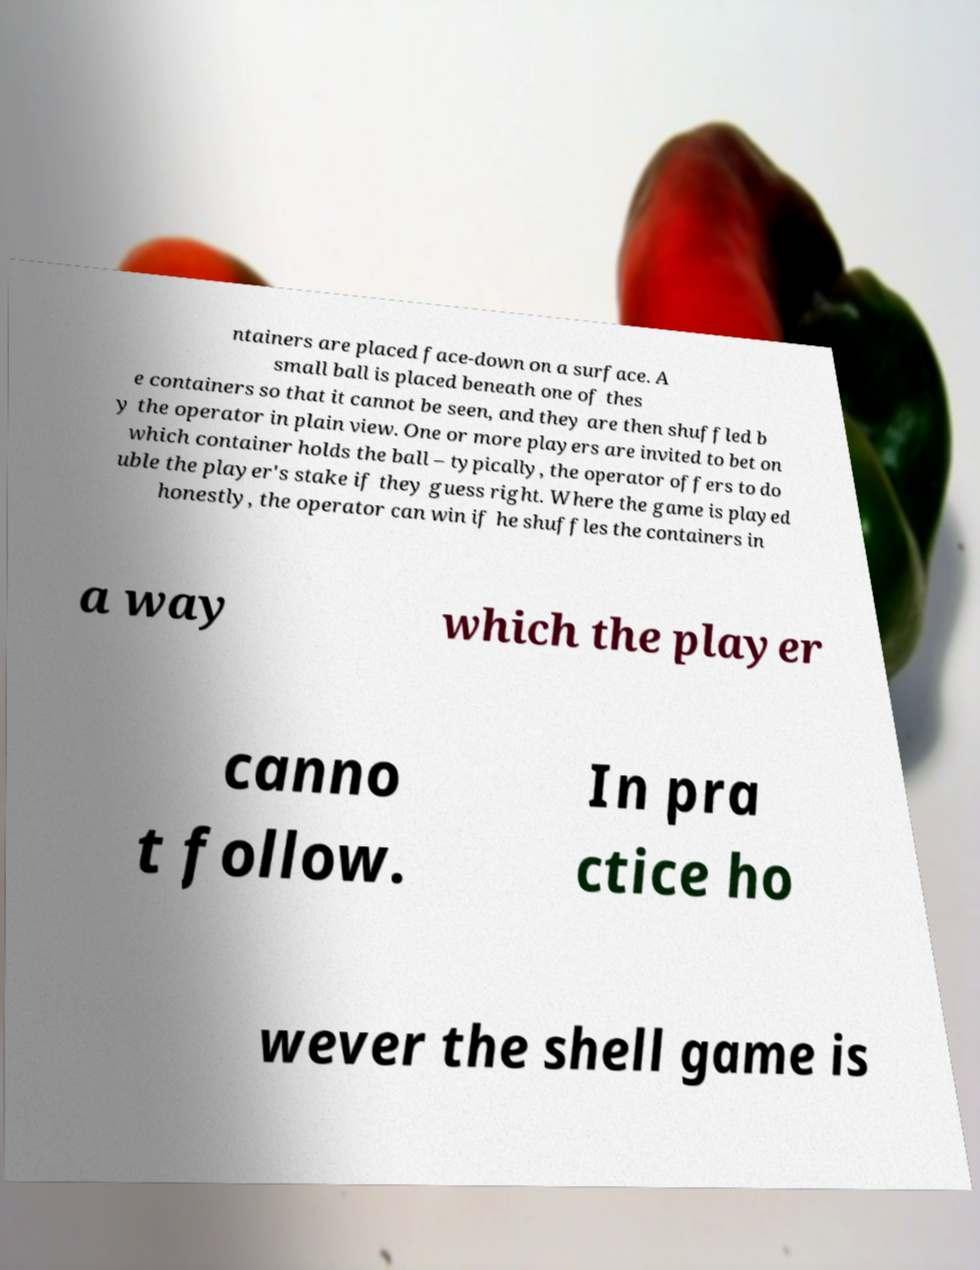Could you assist in decoding the text presented in this image and type it out clearly? ntainers are placed face-down on a surface. A small ball is placed beneath one of thes e containers so that it cannot be seen, and they are then shuffled b y the operator in plain view. One or more players are invited to bet on which container holds the ball – typically, the operator offers to do uble the player's stake if they guess right. Where the game is played honestly, the operator can win if he shuffles the containers in a way which the player canno t follow. In pra ctice ho wever the shell game is 